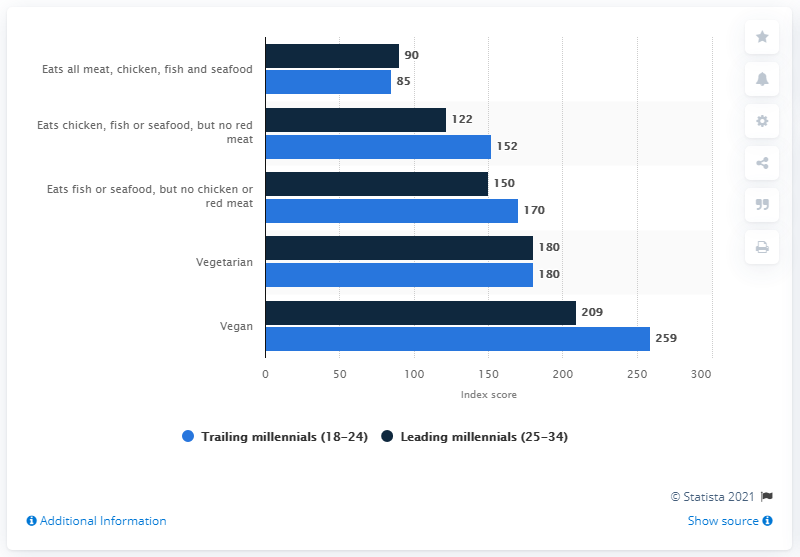Mention a couple of crucial points in this snapshot. In 2015, the index score for Millennials was 259. 